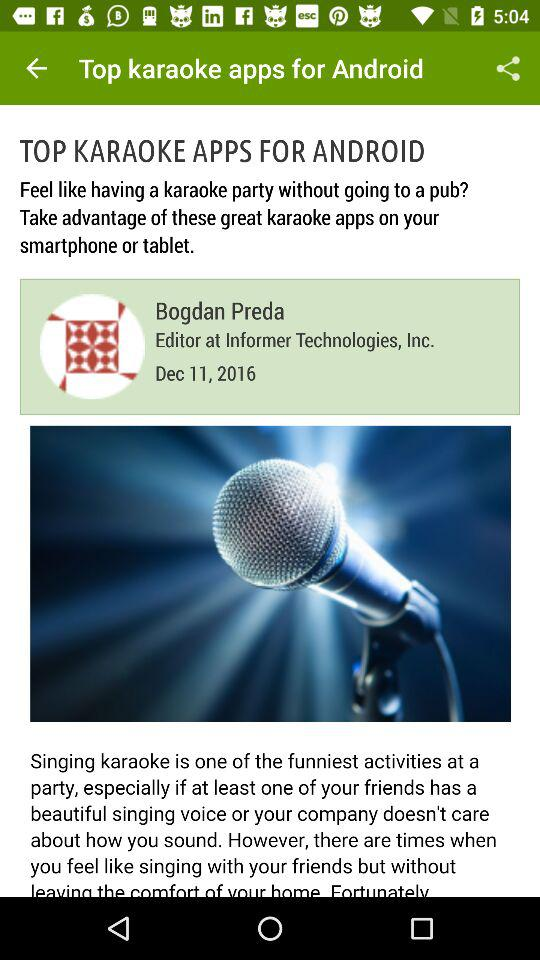What is the name of application?
When the provided information is insufficient, respond with <no answer>. <no answer> 